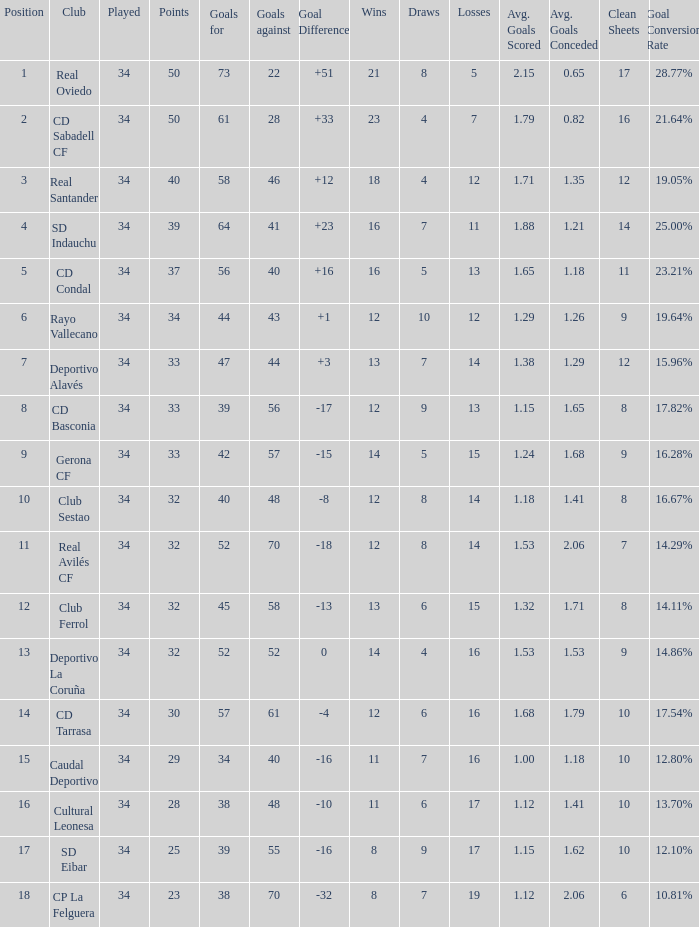Which Wins have a Goal Difference larger than 0, and Goals against larger than 40, and a Position smaller than 6, and a Club of sd indauchu? 16.0. 